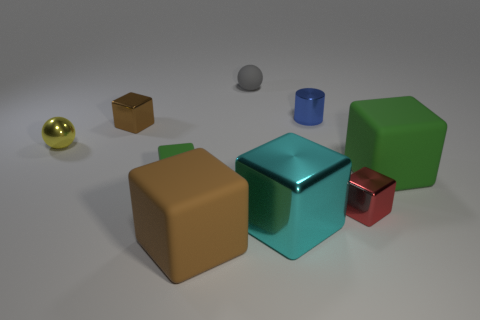Are there any other spheres that have the same material as the gray ball?
Keep it short and to the point. No. How many things are cyan metal objects left of the blue metal object or brown metallic cubes?
Make the answer very short. 2. Do the object in front of the big cyan metallic block and the small red thing have the same material?
Your response must be concise. No. Is the red thing the same shape as the large green rubber thing?
Your answer should be very brief. Yes. What number of balls are in front of the small metal cylinder that is right of the large shiny cube?
Provide a short and direct response. 1. There is another thing that is the same shape as the tiny yellow object; what is its material?
Your answer should be very brief. Rubber. Do the large block that is behind the red metallic cube and the small cylinder have the same color?
Offer a very short reply. No. Is the material of the gray object the same as the green object that is left of the gray sphere?
Provide a succinct answer. Yes. There is a matte object behind the tiny metallic cylinder; what is its shape?
Offer a very short reply. Sphere. How many other objects are the same material as the small brown cube?
Your response must be concise. 4. 